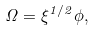Convert formula to latex. <formula><loc_0><loc_0><loc_500><loc_500>\Omega = \xi ^ { 1 / 2 } \phi ,</formula> 